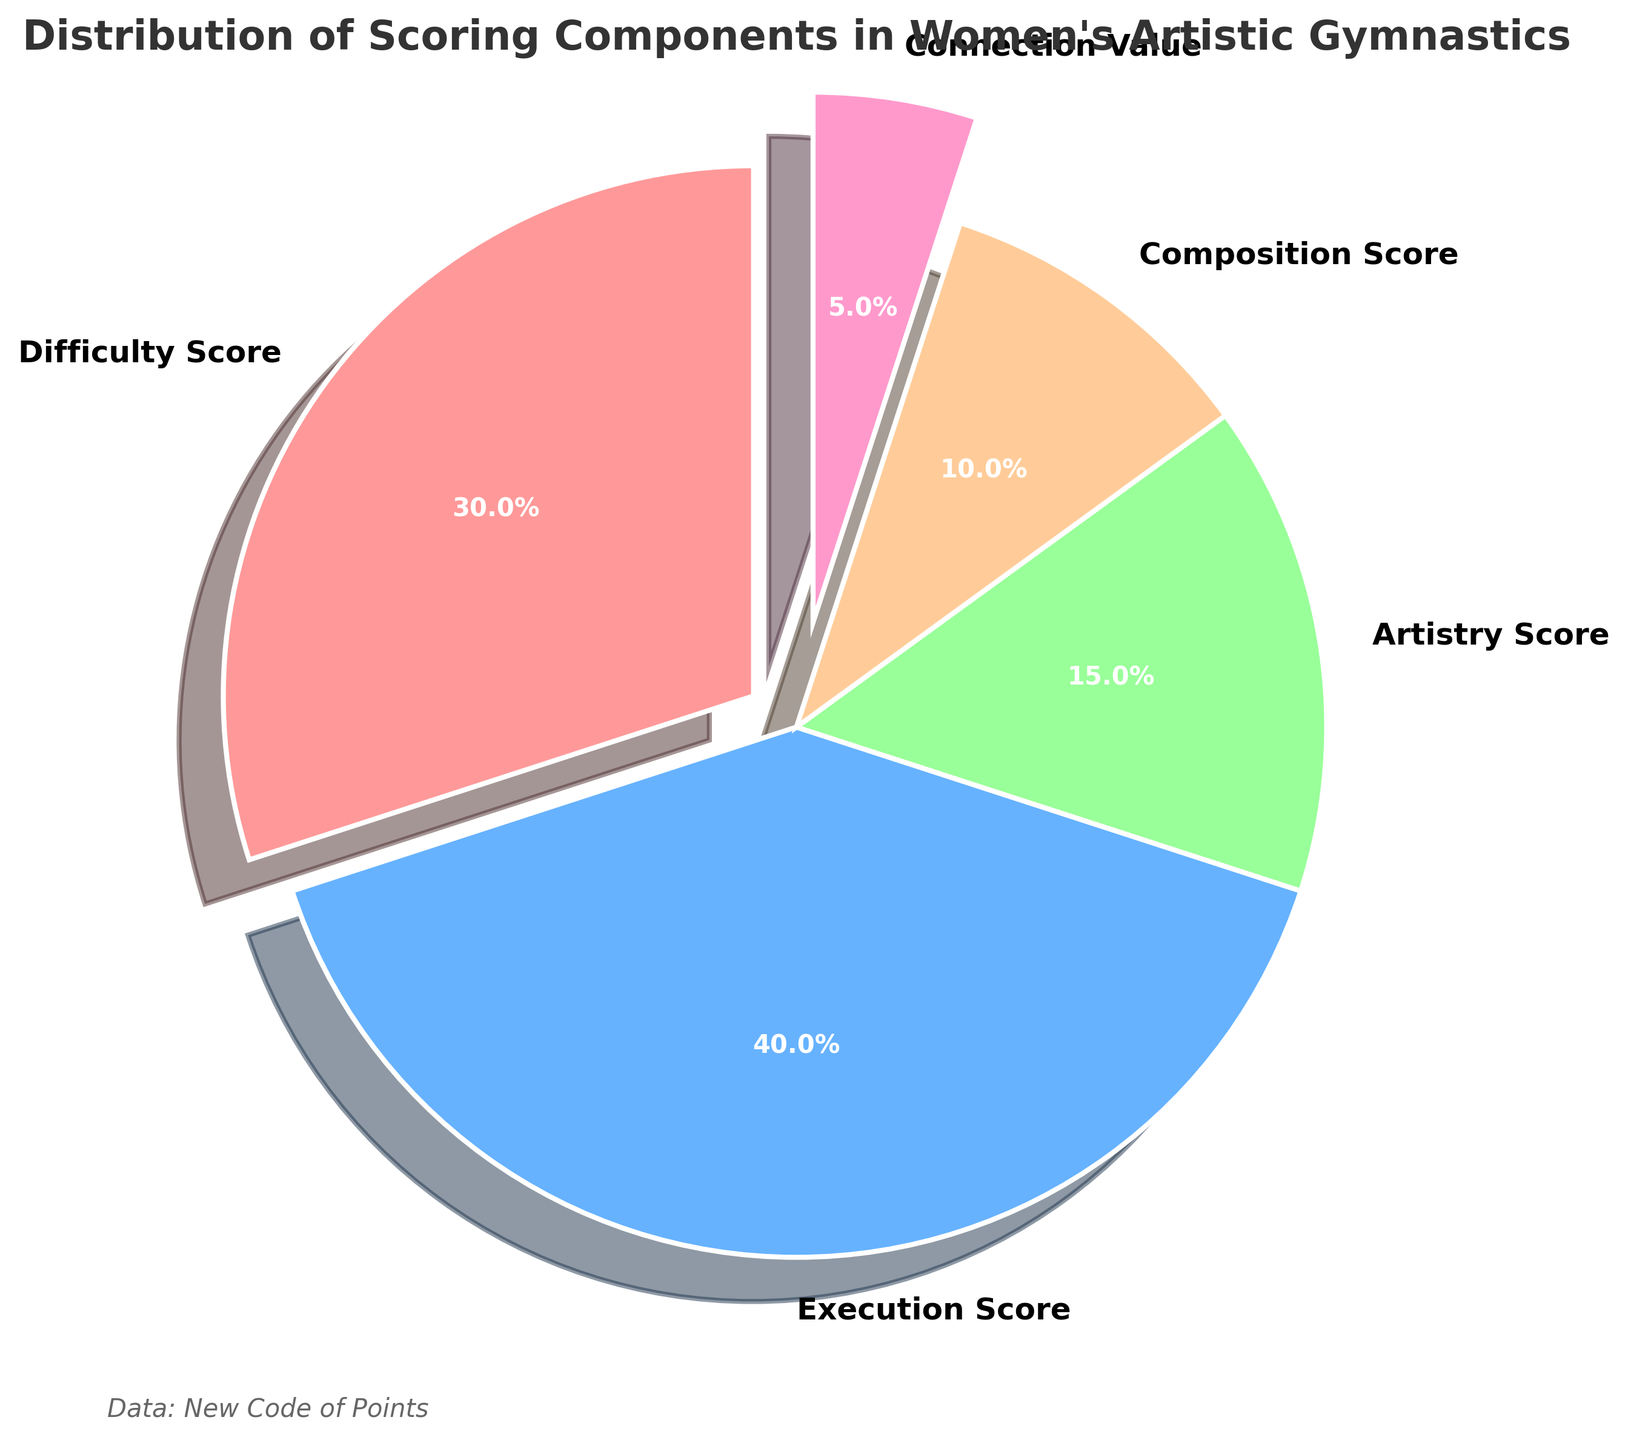Which component has the highest percentage? By looking at the pie chart, identify the component that occupies the largest section. The component labeled "Execution Score" takes up the most space, which corresponds to a 40% share.
Answer: Execution Score Which component has the lowest percentage? By observing the smallest slice in the pie chart, one can see that "Connection Value" is the smallest, which is labeled with 5%.
Answer: Connection Value How much more percentage does the Execution Score have compared to the Difficulty Score? The Execution Score is 40%, and the Difficulty Score is 30%. The difference is calculated as 40% - 30% = 10%.
Answer: 10% What is the combined percentage of the Artistry Score and Composition Score? The Artistry Score is 15% and the Composition Score is 10%. Adding them together gives 15% + 10% = 25%.
Answer: 25% Which component is represented in pink? By examining the colors in the chart, the pink section corresponds to the "Difficulty Score" which is followed by the label and percentage 30%.
Answer: Difficulty Score Are there more components with a percentage greater than or equal to 30% or less than 30%? There are only two components with a percentage greater than or equal to 30%: "Difficulty Score" and "Execution Score", which totals 2 components. The remaining three components are below 30% ("Artistry Score", "Composition Score", and "Connection Value"), which totals 3 components. Therefore, there are more components with a percentage less than 30%.
Answer: Less than 30% What is the average percentage of all components? To find the average, sum the percentages of all components and divide by the number of components. The sum is 30% + 40% + 15% + 10% + 5% = 100%. Dividing by 5 components yields an average of 100% / 5 = 20%.
Answer: 20% If you combine the Difficulty Score and Artistry Score, would their percentage be greater than the Execution Score? The Difficulty Score is 30% and the Artistry Score is 15%. Adding them gives 30% + 15% = 45%. The Execution Score is 40%, so 45% is greater than 40%.
Answer: Yes What is the difference in percentage between the largest and smallest component? The largest component is the Execution Score at 40%, and the smallest is Connection Value at 5%. The difference is 40% - 5% = 35%.
Answer: 35% Which component is located clockwise next to the Execution Score? By looking at the pie chart starting from the Execution Score section and moving clockwise, the next component is labeled "Artistry Score" with 15%.
Answer: Artistry Score 